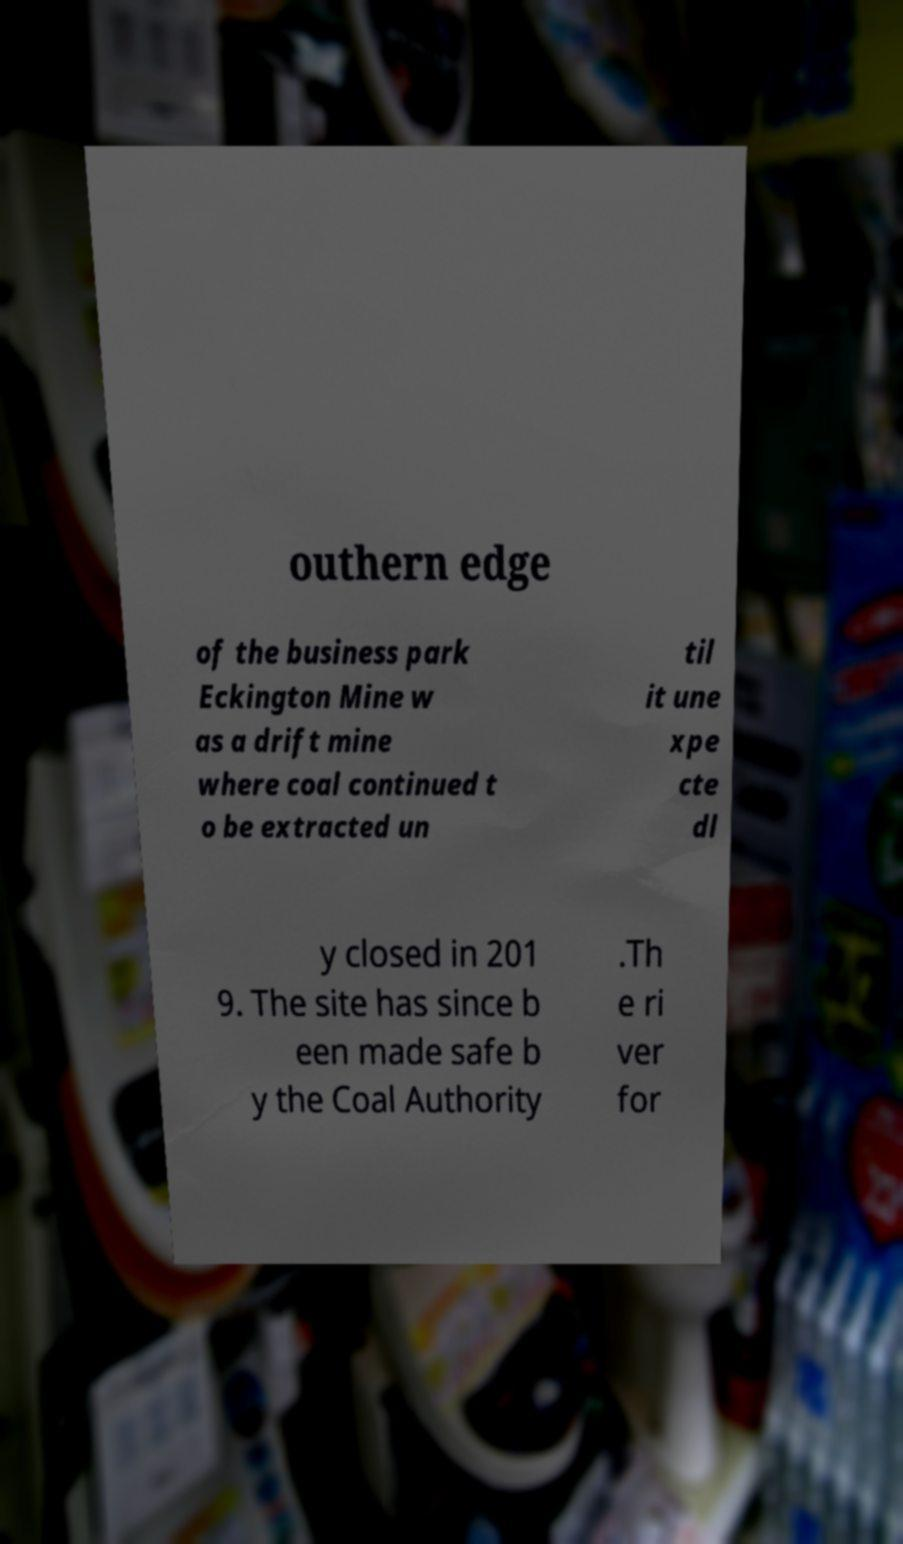Could you assist in decoding the text presented in this image and type it out clearly? outhern edge of the business park Eckington Mine w as a drift mine where coal continued t o be extracted un til it une xpe cte dl y closed in 201 9. The site has since b een made safe b y the Coal Authority .Th e ri ver for 